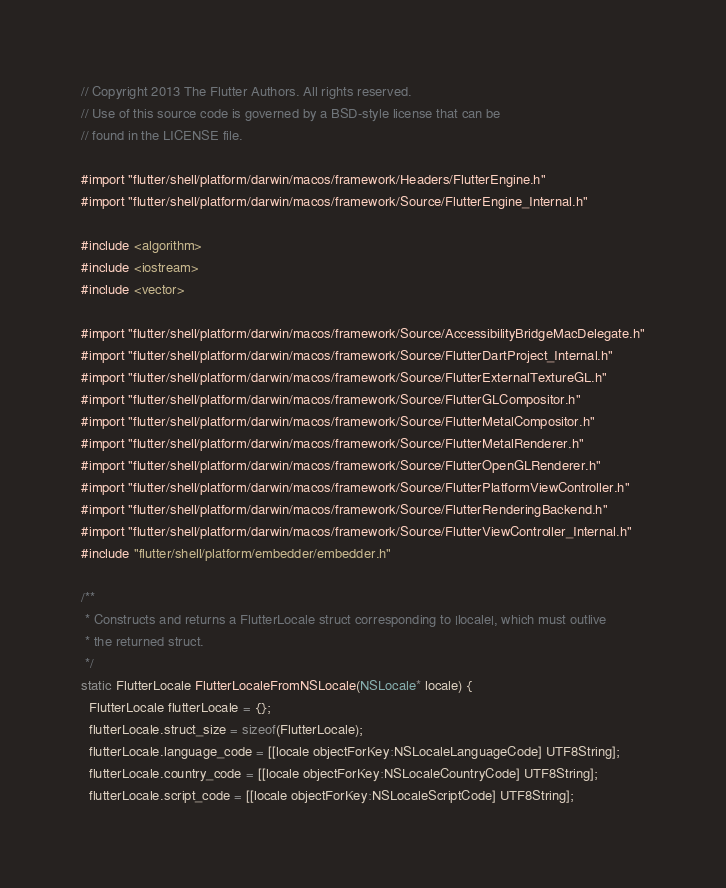<code> <loc_0><loc_0><loc_500><loc_500><_ObjectiveC_>// Copyright 2013 The Flutter Authors. All rights reserved.
// Use of this source code is governed by a BSD-style license that can be
// found in the LICENSE file.

#import "flutter/shell/platform/darwin/macos/framework/Headers/FlutterEngine.h"
#import "flutter/shell/platform/darwin/macos/framework/Source/FlutterEngine_Internal.h"

#include <algorithm>
#include <iostream>
#include <vector>

#import "flutter/shell/platform/darwin/macos/framework/Source/AccessibilityBridgeMacDelegate.h"
#import "flutter/shell/platform/darwin/macos/framework/Source/FlutterDartProject_Internal.h"
#import "flutter/shell/platform/darwin/macos/framework/Source/FlutterExternalTextureGL.h"
#import "flutter/shell/platform/darwin/macos/framework/Source/FlutterGLCompositor.h"
#import "flutter/shell/platform/darwin/macos/framework/Source/FlutterMetalCompositor.h"
#import "flutter/shell/platform/darwin/macos/framework/Source/FlutterMetalRenderer.h"
#import "flutter/shell/platform/darwin/macos/framework/Source/FlutterOpenGLRenderer.h"
#import "flutter/shell/platform/darwin/macos/framework/Source/FlutterPlatformViewController.h"
#import "flutter/shell/platform/darwin/macos/framework/Source/FlutterRenderingBackend.h"
#import "flutter/shell/platform/darwin/macos/framework/Source/FlutterViewController_Internal.h"
#include "flutter/shell/platform/embedder/embedder.h"

/**
 * Constructs and returns a FlutterLocale struct corresponding to |locale|, which must outlive
 * the returned struct.
 */
static FlutterLocale FlutterLocaleFromNSLocale(NSLocale* locale) {
  FlutterLocale flutterLocale = {};
  flutterLocale.struct_size = sizeof(FlutterLocale);
  flutterLocale.language_code = [[locale objectForKey:NSLocaleLanguageCode] UTF8String];
  flutterLocale.country_code = [[locale objectForKey:NSLocaleCountryCode] UTF8String];
  flutterLocale.script_code = [[locale objectForKey:NSLocaleScriptCode] UTF8String];</code> 